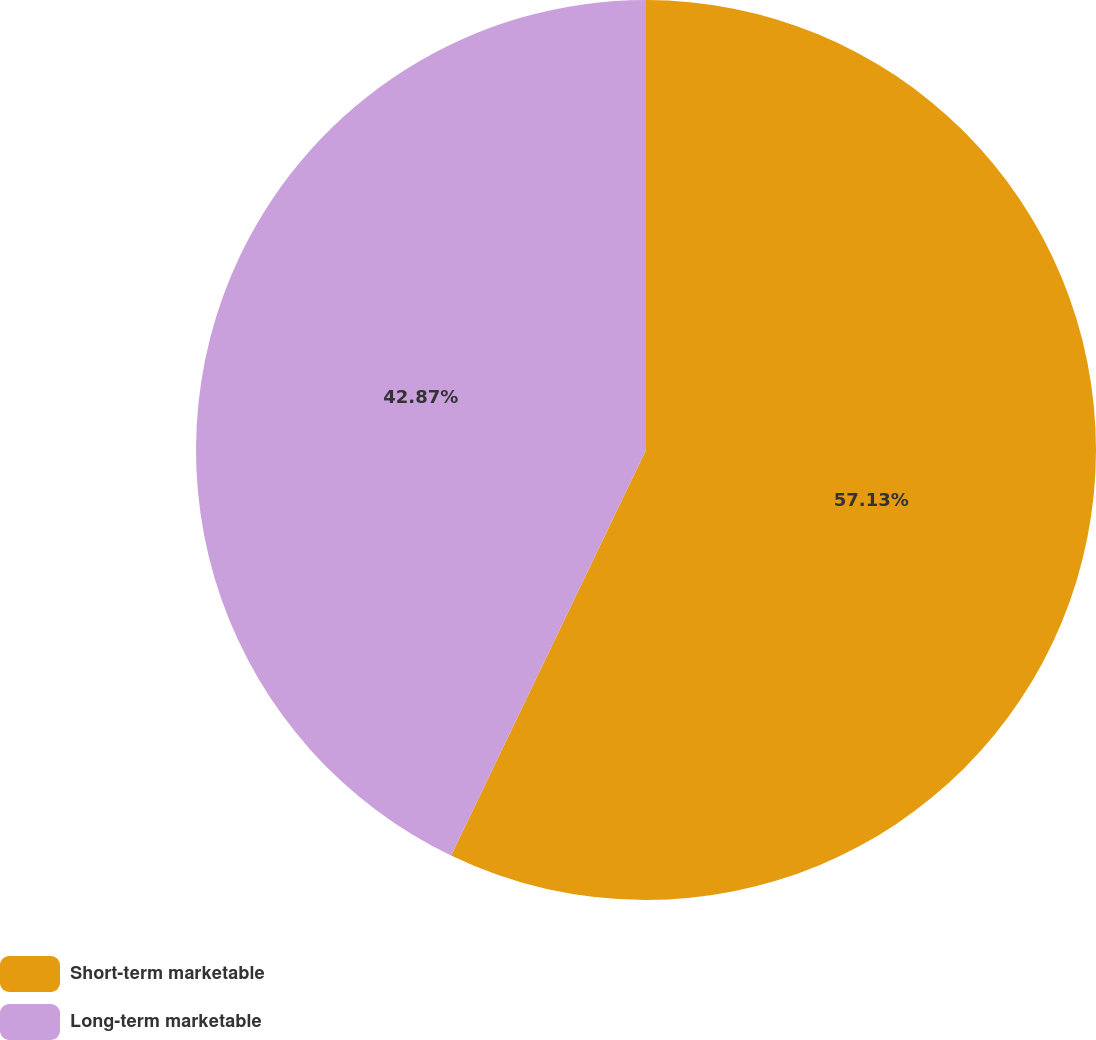Convert chart. <chart><loc_0><loc_0><loc_500><loc_500><pie_chart><fcel>Short-term marketable<fcel>Long-term marketable<nl><fcel>57.13%<fcel>42.87%<nl></chart> 